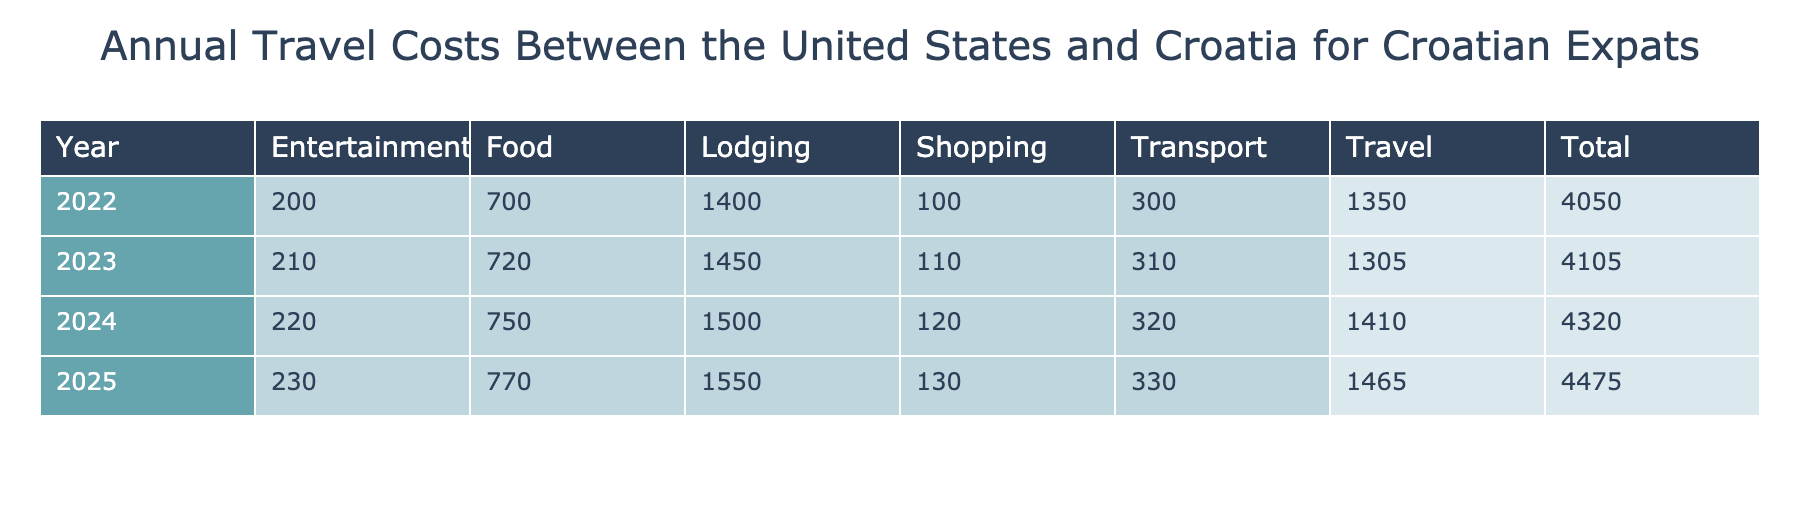What was the total cost for meals and dining out in 2023? In 2023, the cost for meals and dining out is listed as 720 USD.
Answer: 720 USD What was the cost difference for round-trip flights from 2022 to 2024? The cost in 2022 was 1200 USD and in 2024 it was 1250 USD. The difference is 1250 - 1200 = 50 USD.
Answer: 50 USD Did the total travel costs increase from 2022 to 2023? To determine this, sum the total costs for each year. The total for 2022 is 1200 + 1400 + 150 + 300 + 700 + 200 + 100 = 4050 USD, and for 2023, it's 1150 + 1450 + 155 + 310 + 720 + 210 + 110 = 5105 USD. Since 5105 > 4050, the costs did increase.
Answer: Yes What was the category with the highest cost in 2024? In 2024, the costs per category are: Travel (1250 USD), Lodging (1500 USD), Transport (320 USD), Food (750 USD), Entertainment (220 USD), and Shopping (120 USD). Among these, Lodging at 1500 USD has the highest cost.
Answer: Lodging What is the average cost of local transportation over the four years provided? The costs for local transportation are: 300 USD (2022), 310 USD (2023), 320 USD (2024), and 330 USD (2025). To find the average, sum these values: 300 + 310 + 320 + 330 = 1260 USD. Then divide by 4 (the number of years): 1260 / 4 = 315 USD.
Answer: 315 USD What is the total amount spent on shopping from 2022 to 2025? The costs for shopping are: 100 USD (2022), 110 USD (2023), 120 USD (2024), and 130 USD (2025). To find the total, sum these values: 100 + 110 + 120 + 130 = 460 USD.
Answer: 460 USD Did expenses in the category of entertainment increase every year from 2022 to 2025? The entertainment costs are as follows: 200 USD (2022), 210 USD (2023), 220 USD (2024), and 230 USD (2025). Each year shows an increase: 210 > 200, 220 > 210, and 230 > 220, so they did indeed increase each year.
Answer: Yes What is the total cost of travel insurance over the specified years? The costs of travel insurance are: 150 USD (2022), 155 USD (2023), 160 USD (2024), and 165 USD (2025). Summing these provides the total: 150 + 155 + 160 + 165 = 630 USD.
Answer: 630 USD 